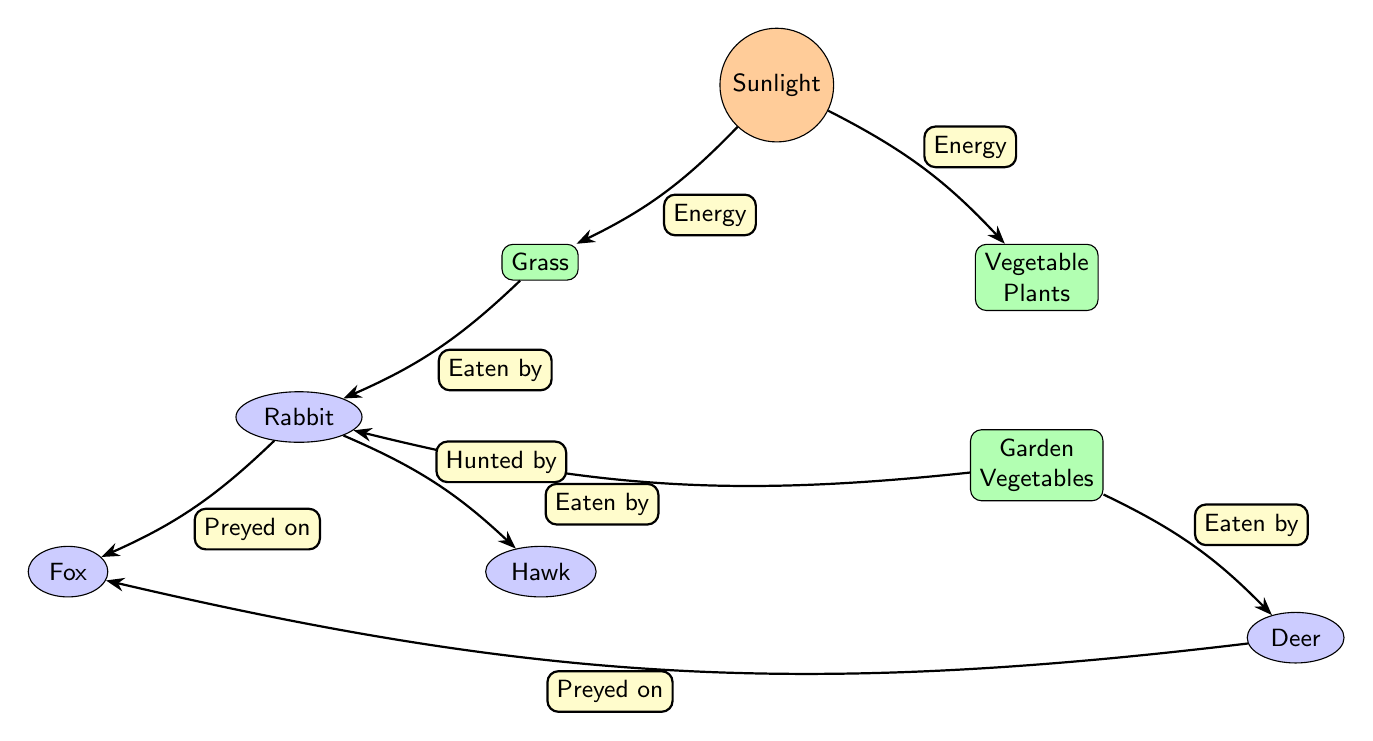What is the primary energy source in this food chain? The diagram shows a node labeled "Sunlight," which indicates that it is the primary energy source for the food chain.
Answer: Sunlight How many consumer nodes are there? By counting the ellipses in the diagram, we identify three consumer nodes: Rabbit, Deer, and Fox.
Answer: 3 Which producer is eaten by the Rabbit? The diagram indicates that both "Grass" and "Garden Vegetables" are eaten by the Rabbit, but specifically the label shows "Eaten by" leading from Grass to Rabbit.
Answer: Grass Who is the Rabbit preyed on by? The diagram includes a directed edge from Rabbit to Fox labeled "Preyed on," indicating that the Fox preys on the Rabbit.
Answer: Fox What types of producers are present in the diagram? There are two producers shown: "Grass" and "Vegetable Plants," both of which are responsible for producing energy from sunlight.
Answer: Grass and Vegetable Plants Which consumer is at the top of the food chain? The Hawk is indicated as the predator that hunts the Rabbit, making it the top consumer in this food chain structure.
Answer: Hawk How many total edges are in the diagram? Counting all the directional arrows leads us to a total of seven edges representing different interactions between the nodes.
Answer: 7 Which producer is consumed by the Deer? The diagram explicitly shows that "Garden Vegetables" is the producer that is eaten by the Deer.
Answer: Garden Vegetables Who preys on both the Rabbit and Deer? The Fox preys upon both the Rabbit and the Deer, as indicated by the directed edges leading from each animal to the Fox.
Answer: Fox 